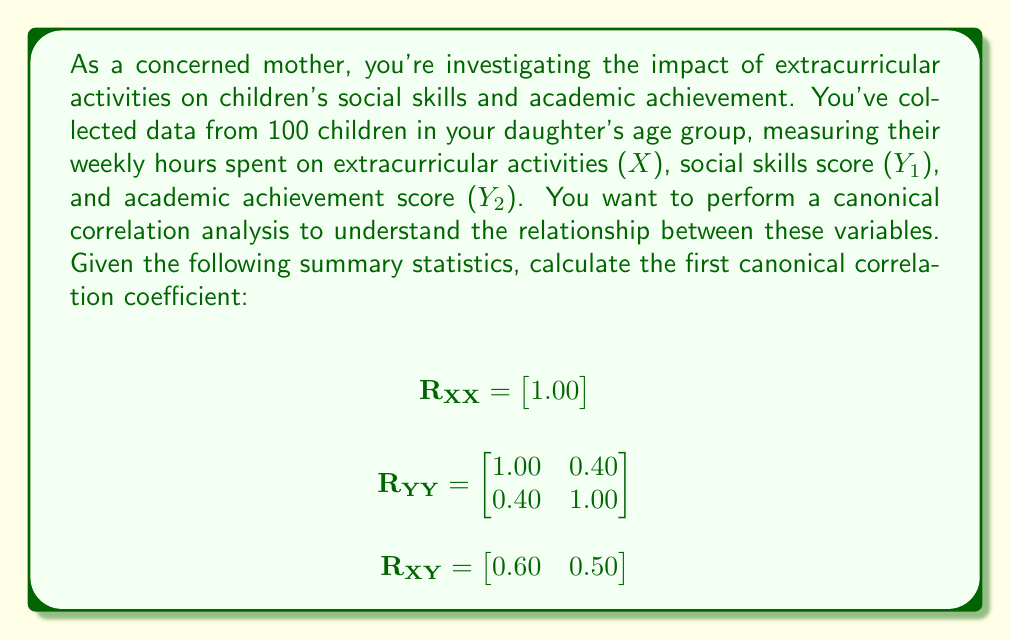Help me with this question. To calculate the first canonical correlation coefficient, we need to follow these steps:

1) First, we need to calculate $\mathbf{R_{YY}^{-1}}$:

   $$\mathbf{R_{YY}^{-1}} = \frac{1}{1-0.4^2} \begin{bmatrix} 1.00 & -0.40 \\ -0.40 & 1.00 \end{bmatrix} = \begin{bmatrix} 1.19 & -0.48 \\ -0.48 & 1.19 \end{bmatrix}$$

2) Next, we calculate $\mathbf{R_{XY}R_{YY}^{-1}R_{YX}}$:

   $$\mathbf{R_{XY}R_{YY}^{-1}R_{YX}} = \begin{bmatrix} 0.60 & 0.50 \end{bmatrix} \begin{bmatrix} 1.19 & -0.48 \\ -0.48 & 1.19 \end{bmatrix} \begin{bmatrix} 0.60 \\ 0.50 \end{bmatrix}$$

   $$= \begin{bmatrix} 0.714 & -0.288 \end{bmatrix} \begin{bmatrix} 0.60 \\ 0.50 \end{bmatrix} = 0.4284 - 0.144 = 0.2844$$

3) The first canonical correlation coefficient is the square root of this value:

   $$r_c = \sqrt{0.2844} = 0.5333$$

This coefficient represents the maximum correlation between any linear combination of the X variables (in this case, just one variable) and any linear combination of the Y variables. A value of 0.5333 suggests a moderate positive relationship between extracurricular activities and the combination of social skills and academic achievement.
Answer: $r_c = 0.5333$ 